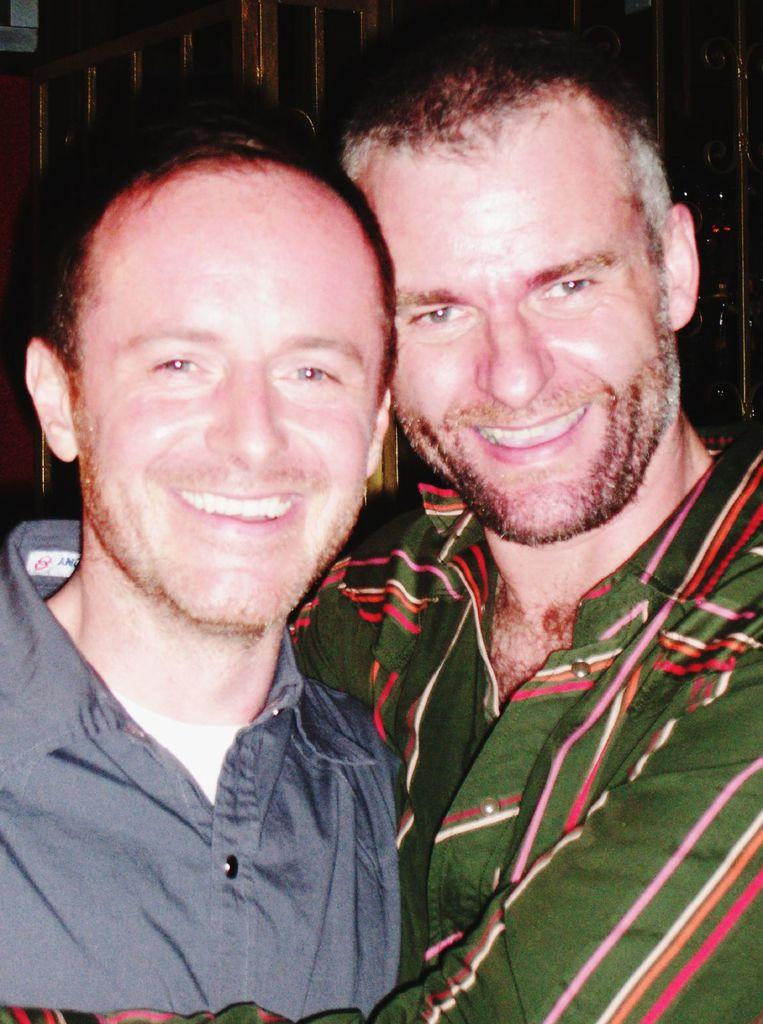How many people are in the image? There are two men in the image. What are the men doing in the image? The men are standing and smiling. Can you describe the interaction between the two men? The man on the right is holding the other man. What can be seen in the background of the image? There is a wall in the background of the image. How many cats are visible in the image? There are no cats present in the image. What is the source of shame for the men in the image? There is no indication of shame in the image; the men are smiling and interacting positively. 